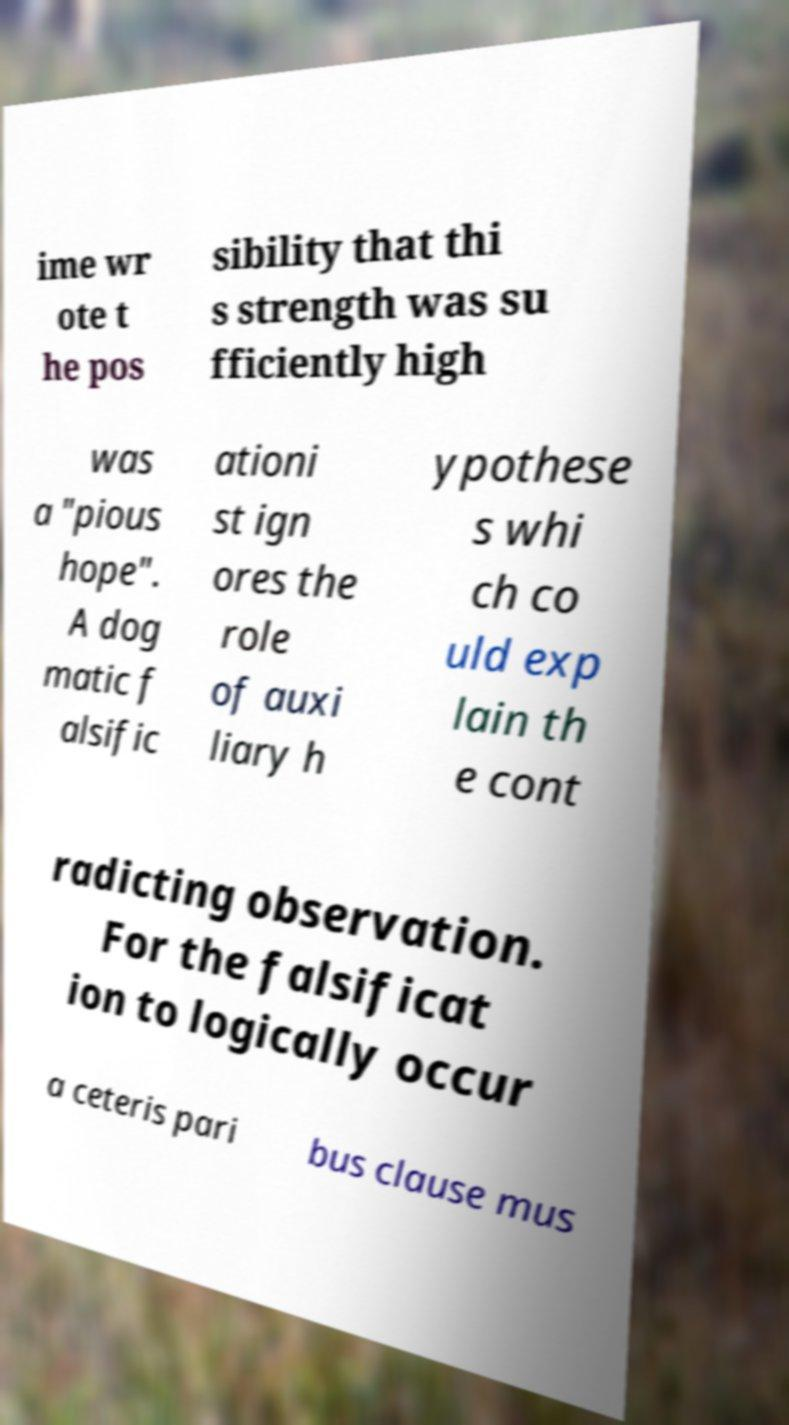Can you accurately transcribe the text from the provided image for me? ime wr ote t he pos sibility that thi s strength was su fficiently high was a "pious hope". A dog matic f alsific ationi st ign ores the role of auxi liary h ypothese s whi ch co uld exp lain th e cont radicting observation. For the falsificat ion to logically occur a ceteris pari bus clause mus 